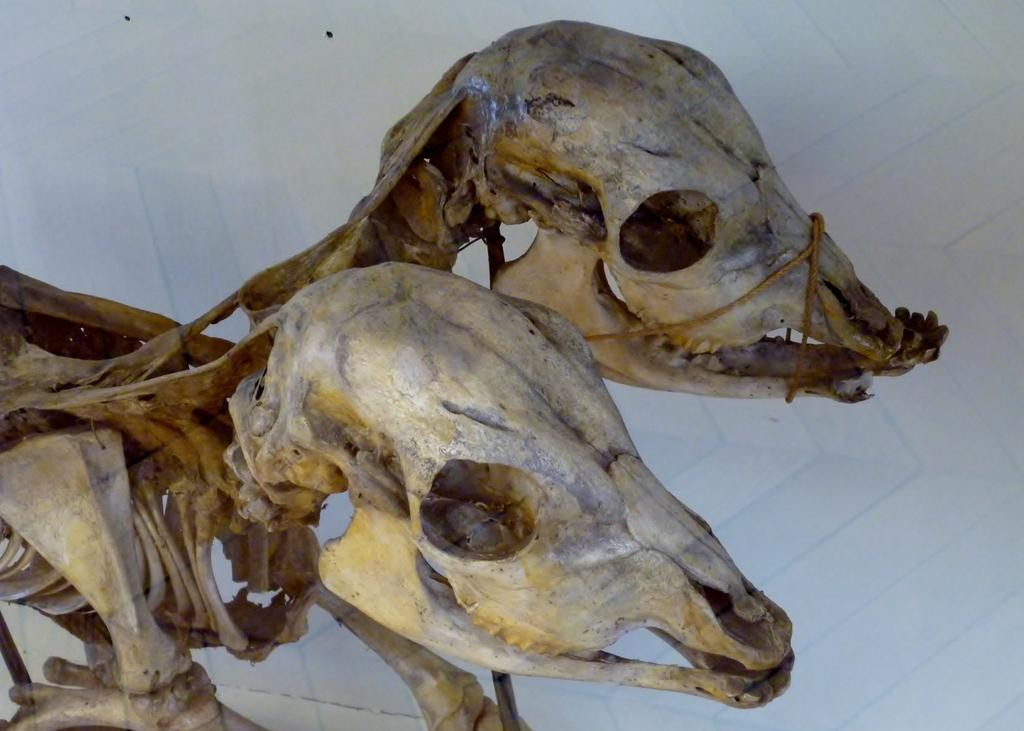What is the main subject of the image? The main subject of the image is skeletons. What is the color of the background in the image? The background of the image is white in color. How many bikes are being shown by the skeletons in the image? There are no bikes present in the image. What type of locket is being worn by the skeletons in the image? There are no lockets visible on the skeletons in the image. 